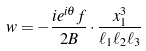Convert formula to latex. <formula><loc_0><loc_0><loc_500><loc_500>w = - \frac { i e ^ { i \theta } f } { 2 B } \cdot \frac { x _ { 1 } ^ { 3 } } { \ell _ { 1 } \ell _ { 2 } \ell _ { 3 } }</formula> 